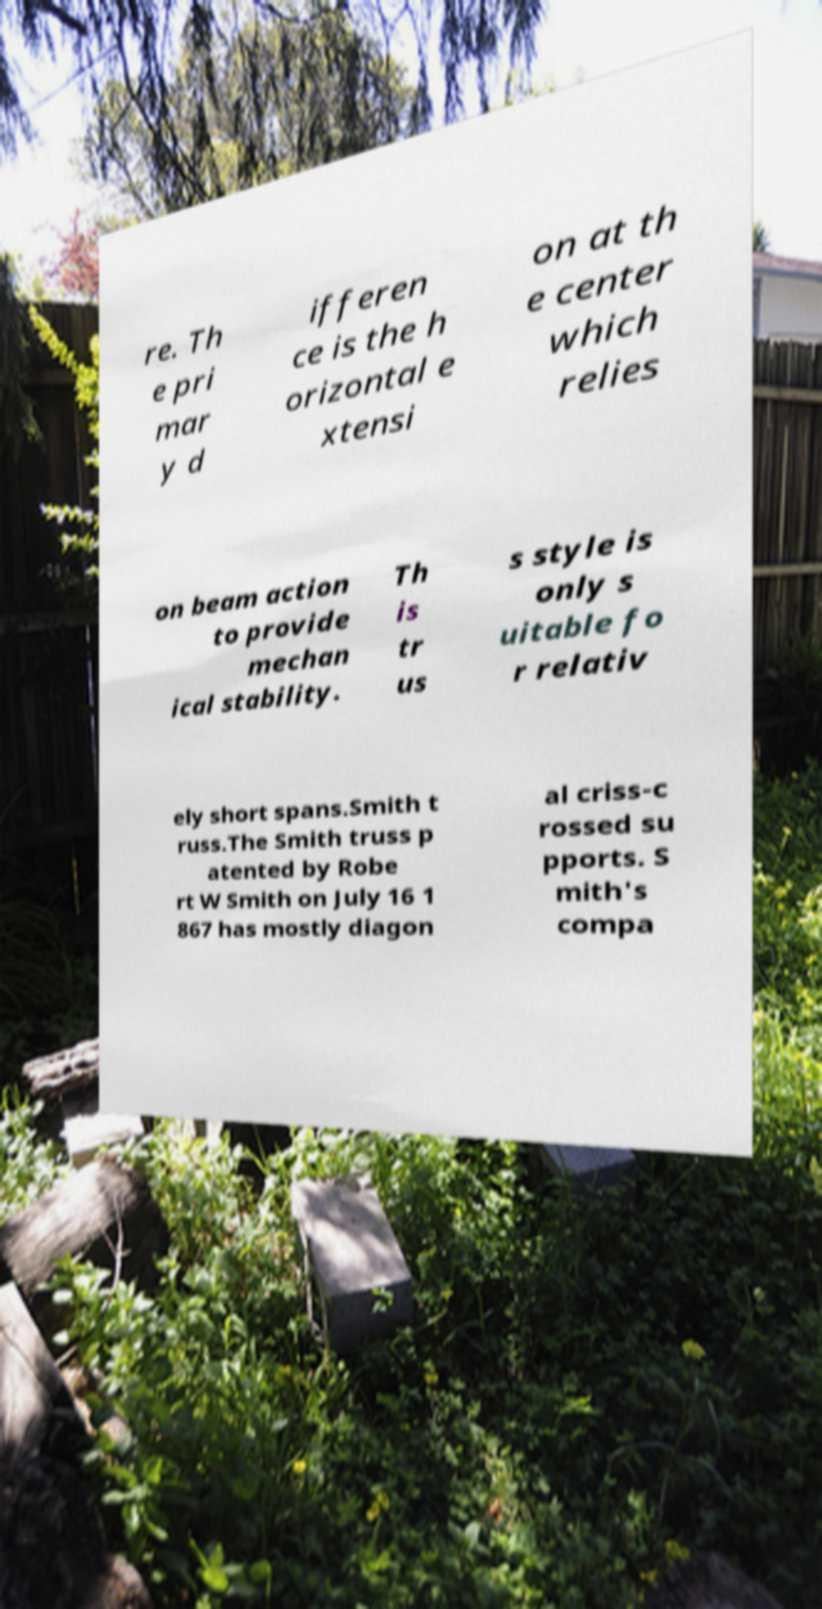Can you read and provide the text displayed in the image?This photo seems to have some interesting text. Can you extract and type it out for me? re. Th e pri mar y d ifferen ce is the h orizontal e xtensi on at th e center which relies on beam action to provide mechan ical stability. Th is tr us s style is only s uitable fo r relativ ely short spans.Smith t russ.The Smith truss p atented by Robe rt W Smith on July 16 1 867 has mostly diagon al criss-c rossed su pports. S mith's compa 